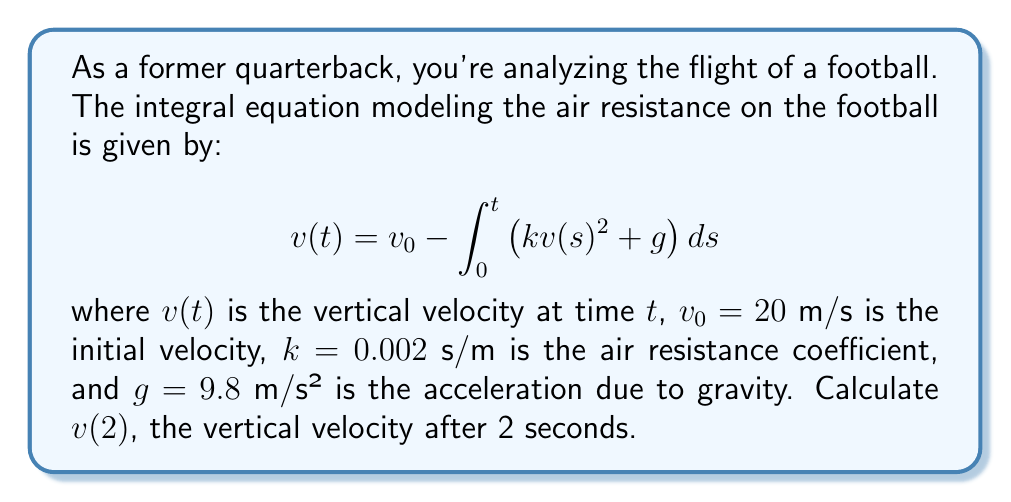Can you solve this math problem? To solve this integral equation, we'll use the following steps:

1) First, we need to convert the integral equation into a differential equation:
   $$\frac{dv}{dt} = -kv^2 - g$$

2) This is a separable differential equation. We can rewrite it as:
   $$\frac{dv}{kv^2 + g} = -dt$$

3) Integrate both sides:
   $$\int \frac{dv}{kv^2 + g} = -\int dt$$

4) The left side can be integrated using the arctangent substitution:
   $$\frac{1}{\sqrt{kg}} \arctan\left(\sqrt{\frac{k}{g}}v\right) = -t + C$$

5) Solve for $v$:
   $$v(t) = \sqrt{\frac{g}{k}} \tan\left(-\sqrt{kg}t + C\right)$$

6) Use the initial condition $v(0) = v_0 = 20$ to find $C$:
   $$20 = \sqrt{\frac{9.8}{0.002}} \tan(C)$$
   $$C = \arctan\left(20\sqrt{\frac{0.002}{9.8}}\right) \approx 0.2827$$

7) Now we can calculate $v(2)$:
   $$v(2) = \sqrt{\frac{9.8}{0.002}} \tan\left(-\sqrt{0.002 \cdot 9.8} \cdot 2 + 0.2827\right)$$

8) Evaluating this expression:
   $$v(2) \approx 10.88 \text{ m/s}$$
Answer: $10.88$ m/s 